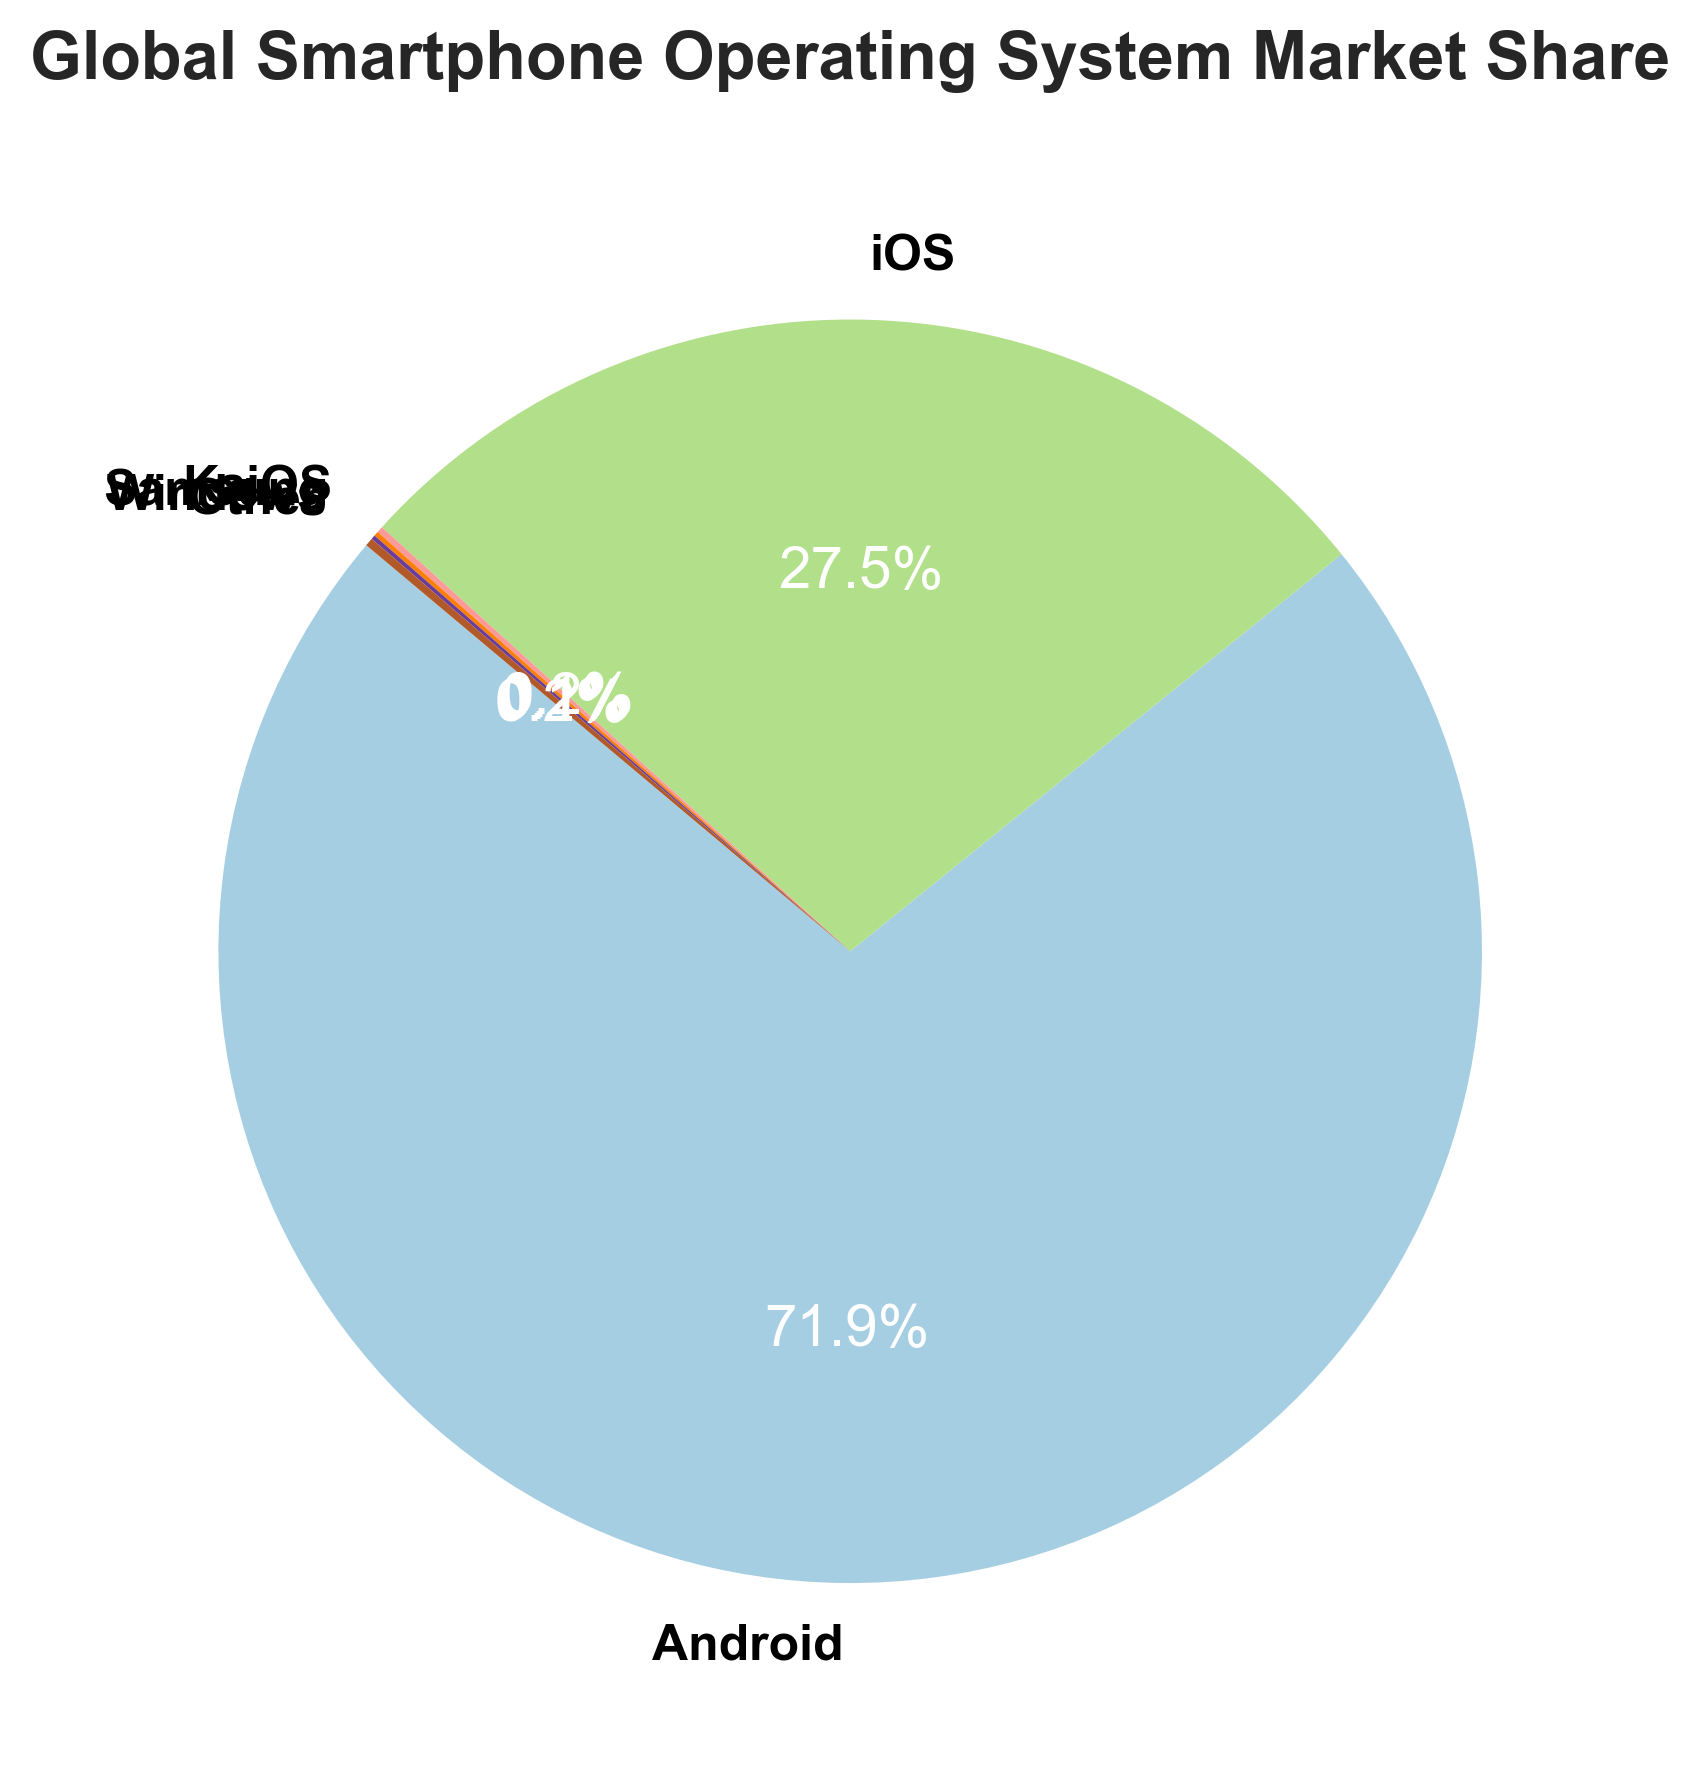Which operating system has the highest market share? The figure clearly shows the market share percentages for each operating system. Android has the largest wedge, labeled with 71.93%.
Answer: Android What is the combined market share of KaiOS, Samsung, and Windows? To find the combined market share, add the percentages for KaiOS (0.16%), Samsung (0.12%), and Windows (0.11%). The sum is 0.16 + 0.12 + 0.11 = 0.39%.
Answer: 0.39% How much larger is Android's market share compared to iOS? Android's market share is 71.93% and iOS's market share is 27.47%. To find the difference, subtract iOS's market share from Android's: 71.93 - 27.47 = 44.46%.
Answer: 44.46% Which operating system has the second smallest market share? By looking at the market shares: KaiOS (0.16%), Samsung (0.12%), Windows (0.11%), Other (0.21%). Samsung has the second smallest market share at 0.12%.
Answer: Samsung What is the market share percentage of the 'Other' category? The figure shows a wedge labeled 'Other' with a market share of 0.21%.
Answer: 0.21% What percentage of the total market is not accounted for by Android and iOS? The combined market share of Android and iOS is 71.93% + 27.47% = 99.4%. Therefore, the market share not accounted for by these two is 100% - 99.4% = 0.6%.
Answer: 0.6% Is the market share of Windows larger or smaller than KaiOS? The market share of Windows is 0.11%, while KaiOS has a market share of 0.16%. Therefore, Windows' market share is smaller.
Answer: Smaller What is the total market share of operating systems excluding Android and iOS? The market shares of KaiOS, Samsung, Windows, and Other are 0.16%, 0.12%, 0.11%, and 0.21% respectively. Summing these gives: 0.16 + 0.12 + 0.11 + 0.21 = 0.60%.
Answer: 0.60% Are there more operating systems with a market share above or below 0.20%? Operating systems with market shares below 0.20% are KaiOS (0.16%), Samsung (0.12%), and Windows (0.11%). The only one below 0.20% is Other (0.21%). There are 3 below 0.20% and 1 above.
Answer: Below 